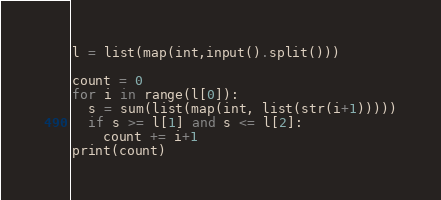Convert code to text. <code><loc_0><loc_0><loc_500><loc_500><_Python_>l = list(map(int,input().split()))

count = 0
for i in range(l[0]):
  s = sum(list(map(int, list(str(i+1)))))
  if s >= l[1] and s <= l[2]:
    count += i+1
print(count)</code> 